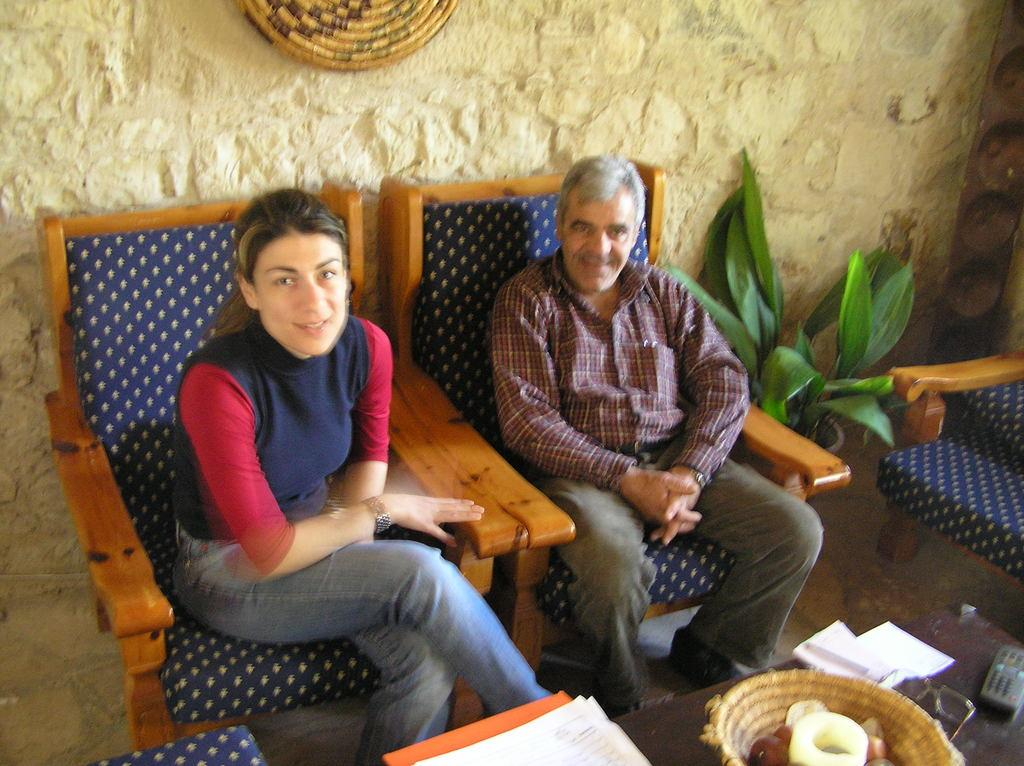How many people are in the image? There are two people in the image. Can you describe the individuals in the image? One person is a man, and the other is a woman. What are the positions of the man and the woman in the image? Both the man and the woman are seated on chairs. What other objects can be seen in the image? There is a plant, a basket, and papers on the table in the image. What type of guitar is the man playing in the image? There is no guitar present in the image; the man is not playing any instrument. 